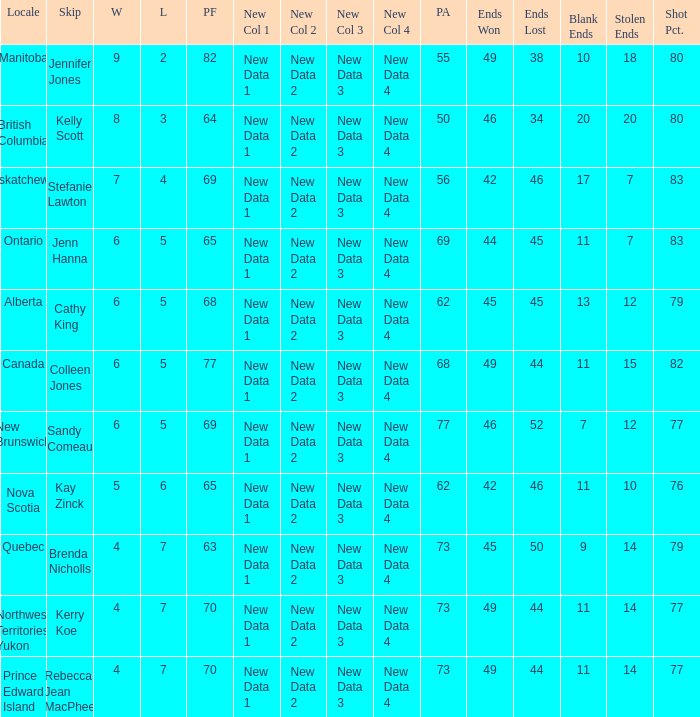What is the total number of ends won when the locale is Northwest Territories Yukon? 1.0. 